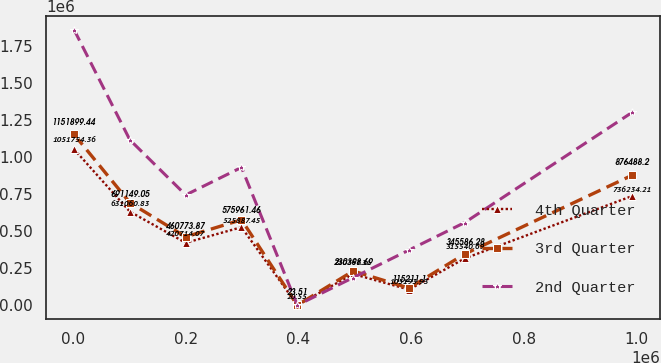<chart> <loc_0><loc_0><loc_500><loc_500><line_chart><ecel><fcel>4th Quarter<fcel>3rd Quarter<fcel>2nd Quarter<nl><fcel>1683.6<fcel>1.05175e+06<fcel>1.1519e+06<fcel>1.85807e+06<nl><fcel>100801<fcel>631061<fcel>691149<fcel>1.11485e+06<nl><fcel>199918<fcel>420714<fcel>460774<fcel>743244<nl><fcel>299036<fcel>525887<fcel>575961<fcel>929048<nl><fcel>398153<fcel>20.55<fcel>23.51<fcel>28.03<nl><fcel>497271<fcel>210367<fcel>230399<fcel>185832<nl><fcel>596388<fcel>105194<fcel>115211<fcel>371636<nl><fcel>695506<fcel>315541<fcel>345586<fcel>557440<nl><fcel>992858<fcel>736234<fcel>876488<fcel>1.30066e+06<nl></chart> 